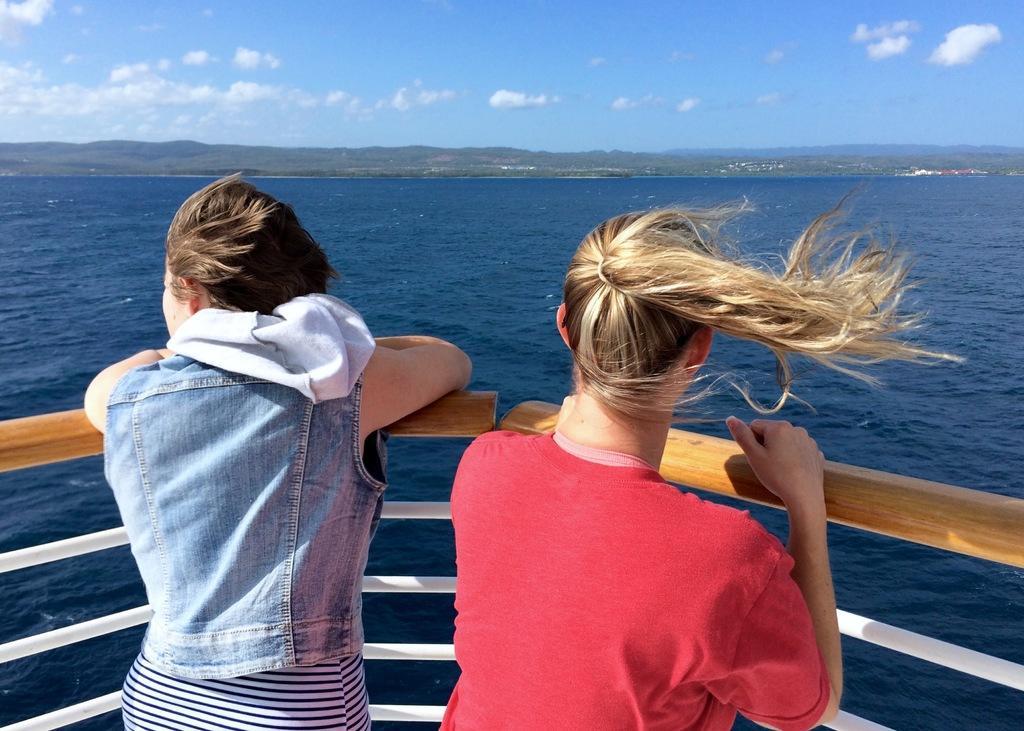Could you give a brief overview of what you see in this image? In this image there are two persons standing at the front part of the ship, the ship is in the water, there are few mountains and some clouds in the sky. 